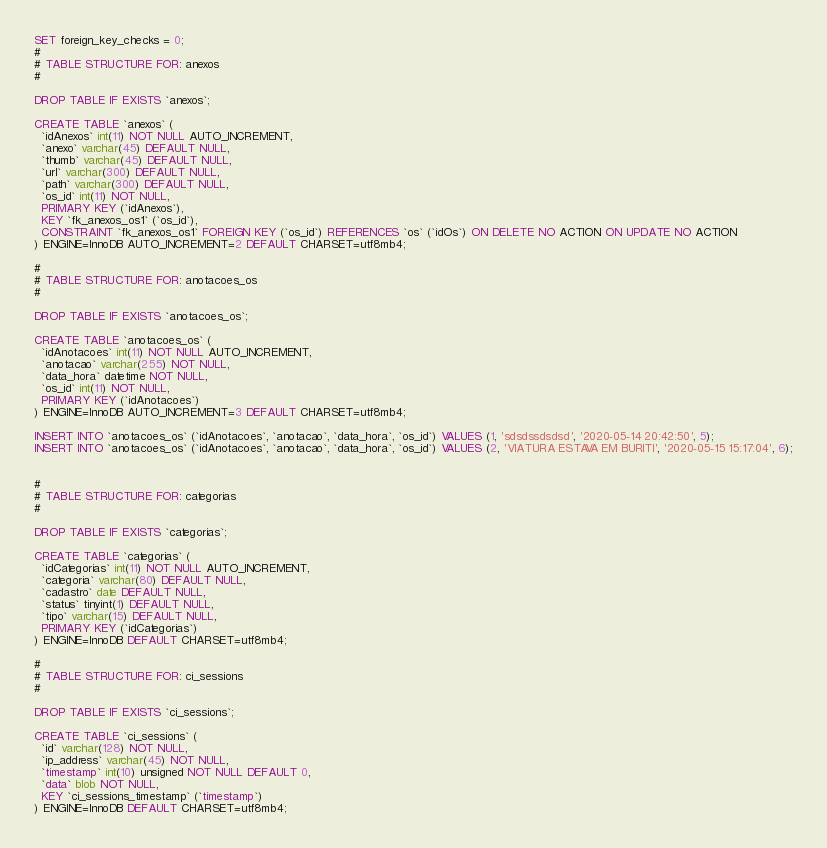<code> <loc_0><loc_0><loc_500><loc_500><_SQL_>SET foreign_key_checks = 0;
#
# TABLE STRUCTURE FOR: anexos
#

DROP TABLE IF EXISTS `anexos`;

CREATE TABLE `anexos` (
  `idAnexos` int(11) NOT NULL AUTO_INCREMENT,
  `anexo` varchar(45) DEFAULT NULL,
  `thumb` varchar(45) DEFAULT NULL,
  `url` varchar(300) DEFAULT NULL,
  `path` varchar(300) DEFAULT NULL,
  `os_id` int(11) NOT NULL,
  PRIMARY KEY (`idAnexos`),
  KEY `fk_anexos_os1` (`os_id`),
  CONSTRAINT `fk_anexos_os1` FOREIGN KEY (`os_id`) REFERENCES `os` (`idOs`) ON DELETE NO ACTION ON UPDATE NO ACTION
) ENGINE=InnoDB AUTO_INCREMENT=2 DEFAULT CHARSET=utf8mb4;

#
# TABLE STRUCTURE FOR: anotacoes_os
#

DROP TABLE IF EXISTS `anotacoes_os`;

CREATE TABLE `anotacoes_os` (
  `idAnotacoes` int(11) NOT NULL AUTO_INCREMENT,
  `anotacao` varchar(255) NOT NULL,
  `data_hora` datetime NOT NULL,
  `os_id` int(11) NOT NULL,
  PRIMARY KEY (`idAnotacoes`)
) ENGINE=InnoDB AUTO_INCREMENT=3 DEFAULT CHARSET=utf8mb4;

INSERT INTO `anotacoes_os` (`idAnotacoes`, `anotacao`, `data_hora`, `os_id`) VALUES (1, 'sdsdssdsdsd', '2020-05-14 20:42:50', 5);
INSERT INTO `anotacoes_os` (`idAnotacoes`, `anotacao`, `data_hora`, `os_id`) VALUES (2, 'VIATURA ESTAVA EM BURITI', '2020-05-15 15:17:04', 6);


#
# TABLE STRUCTURE FOR: categorias
#

DROP TABLE IF EXISTS `categorias`;

CREATE TABLE `categorias` (
  `idCategorias` int(11) NOT NULL AUTO_INCREMENT,
  `categoria` varchar(80) DEFAULT NULL,
  `cadastro` date DEFAULT NULL,
  `status` tinyint(1) DEFAULT NULL,
  `tipo` varchar(15) DEFAULT NULL,
  PRIMARY KEY (`idCategorias`)
) ENGINE=InnoDB DEFAULT CHARSET=utf8mb4;

#
# TABLE STRUCTURE FOR: ci_sessions
#

DROP TABLE IF EXISTS `ci_sessions`;

CREATE TABLE `ci_sessions` (
  `id` varchar(128) NOT NULL,
  `ip_address` varchar(45) NOT NULL,
  `timestamp` int(10) unsigned NOT NULL DEFAULT 0,
  `data` blob NOT NULL,
  KEY `ci_sessions_timestamp` (`timestamp`)
) ENGINE=InnoDB DEFAULT CHARSET=utf8mb4;
</code> 